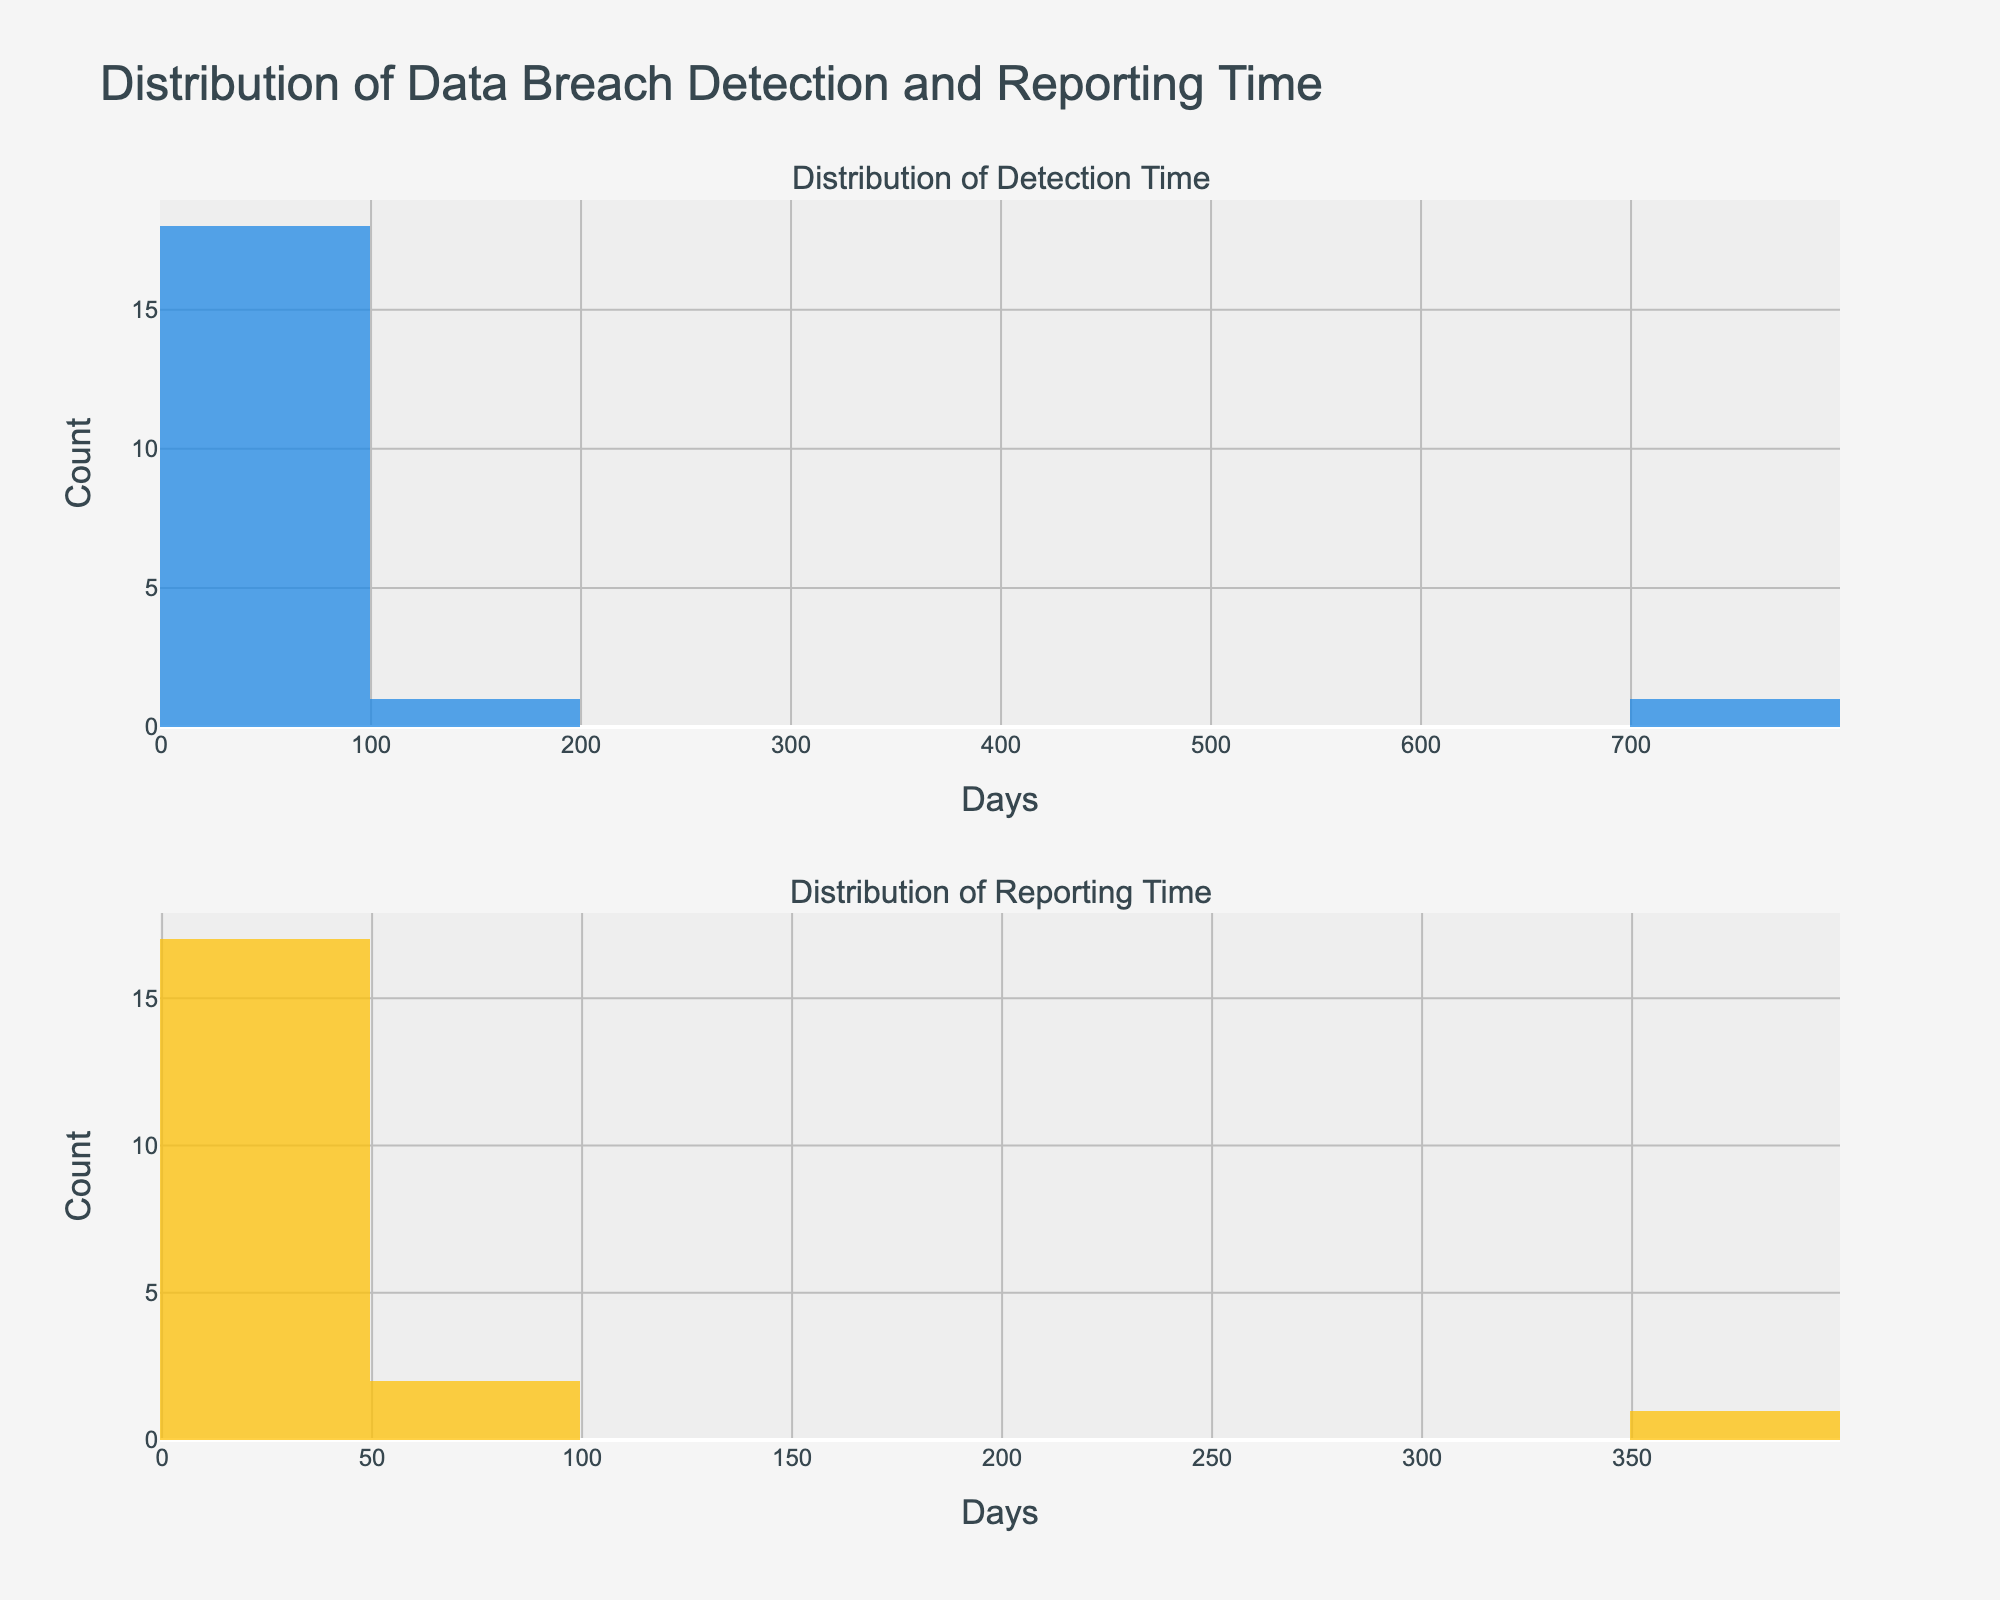Which subplot shows the distribution of reporting times? The title of each subplot indicates the content. The second subplot is titled "Distribution of Reporting Time."
Answer: The second subplot What's the color of the bars representing detection time? By observing the color of the bars in the first subplot, we can see that they are blue.
Answer: Blue What is the range of the x-axis in the first subplot? Inspecting the x-axis of the first histogram, the smallest value starts at 0 and the largest value reaches around 750 days.
Answer: 0 to 750 days Which subplot has a wider distribution of data points? Observing the range of the x-axis in both subplots, the first one spans from 0 to 750, while the second one spans from 0 to 400 days, indicating the first subplot has a wider distribution.
Answer: The first subplot What's the total number of bins in both histograms? From the provided code, both histograms have 10 bins each. Summing up gives us 10 + 10.
Answer: 20 bins Which industry is represented more frequently in the distribution of the detection time? By checking the data table in conjunction with the detection time subplot, we observe that multiple entries (5) belong to the "Technology" industry.
Answer: Technology Is there any data point in the reporting time histogram that stands out significantly? Reviewing the second subplot, there’s a significantly tall bar on the bin near the 365-day mark, representing Uber.
Answer: Yes, at around 365 days On average, do companies take more days to report or to detect data breaches? Comparing the central tendencies from both subplots' distributions, the detection histogram has more spread towards higher days, indicating longer detection times generally.
Answer: More days to detect Between which two ranges of days does the highest number of companies detect breaches? Observing the tallest bar in the first histogram, the highest number of companies detect breaches in the 0-100 days range.
Answer: 0-100 days Is there a company that both detects and reports breaches in less than 10 days? The data shows Google detects in 5 days and reports in 2 days, matching this criterion.
Answer: Yes, Google 